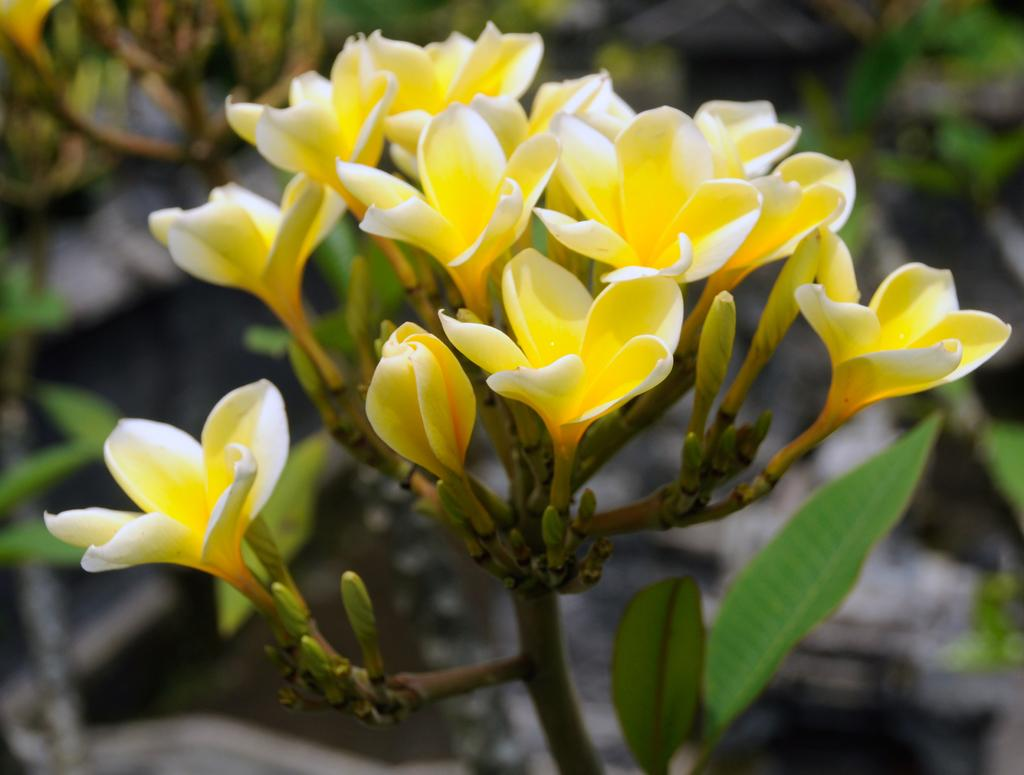What type of plants can be seen in the image? There are flower plants in the image. What color are the flowers on the plants? The flowers are yellow in color. Can you describe the background of the image? The background of the image is blurred. What is the profit margin of the flowers in the image? There is no information about profit margins in the image, as it only shows flower plants with yellow flowers and a blurred background. 